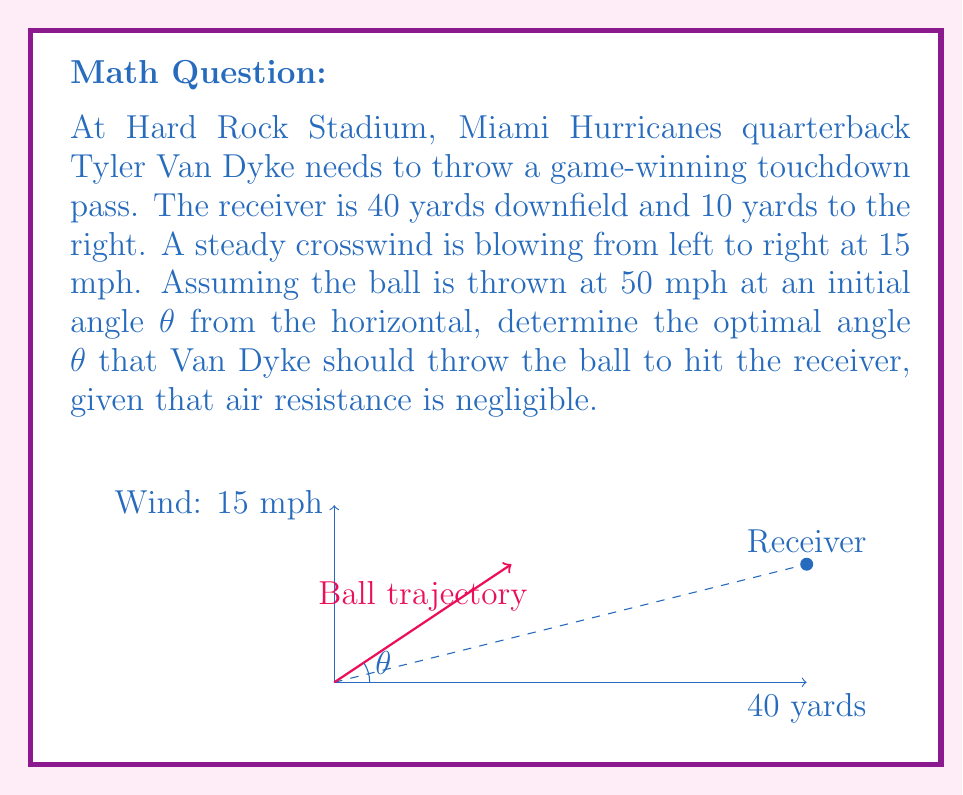Show me your answer to this math problem. Let's approach this problem step-by-step:

1) First, we need to consider the time of flight. The horizontal distance is 40 yards, and the ball's horizontal velocity component is 50 mph * cos(θ).

   Time of flight: $t = \frac{40}{50 \cos(\theta)}$ seconds

2) During this time, the wind will push the ball sideways. The sideways distance due to wind is:

   Wind displacement: $d_{wind} = 15t = \frac{600}{50 \cos(\theta)} = \frac{12}{\cos(\theta)}$ yards

3) The ball needs to travel 10 yards to the right to reach the receiver. Part of this will be due to the wind, and part due to the initial trajectory. Let's call the initial rightward component of the throw $y$:

   $y + \frac{12}{\cos(\theta)} = 10$

4) The rightward component of the throw, $y$, is related to the angle θ:

   $y = 40 \tan(\theta)$

5) Substituting this into our equation:

   $40 \tan(\theta) + \frac{12}{\cos(\theta)} = 10$

6) Multiply both sides by $\cos(\theta)$:

   $40 \sin(\theta) + 12 = 10 \cos(\theta)$

7) Rearrange:

   $40 \sin(\theta) - 10 \cos(\theta) + 12 = 0$

8) This equation can be solved numerically. Using a calculator or computer algebra system, we find:

   $\theta \approx 7.97°$

Thus, Van Dyke should throw the ball at an angle of approximately 7.97° to the horizontal.
Answer: $\theta \approx 7.97°$ 